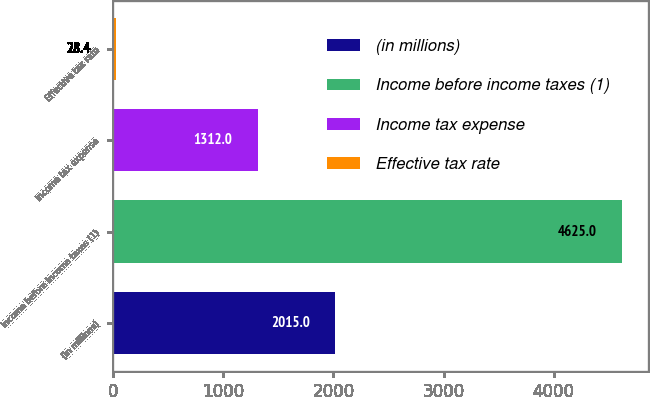<chart> <loc_0><loc_0><loc_500><loc_500><bar_chart><fcel>(in millions)<fcel>Income before income taxes (1)<fcel>Income tax expense<fcel>Effective tax rate<nl><fcel>2015<fcel>4625<fcel>1312<fcel>28.4<nl></chart> 